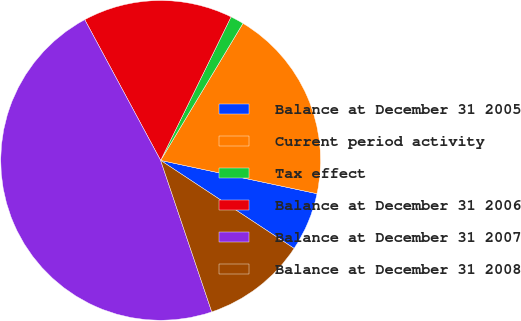Convert chart. <chart><loc_0><loc_0><loc_500><loc_500><pie_chart><fcel>Balance at December 31 2005<fcel>Current period activity<fcel>Tax effect<fcel>Balance at December 31 2006<fcel>Balance at December 31 2007<fcel>Balance at December 31 2008<nl><fcel>5.94%<fcel>19.73%<fcel>1.35%<fcel>15.13%<fcel>47.31%<fcel>10.54%<nl></chart> 